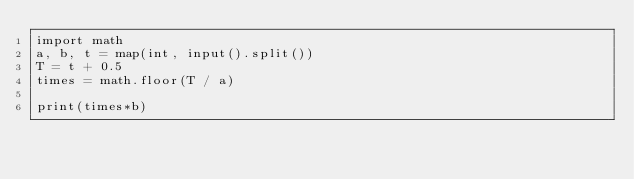<code> <loc_0><loc_0><loc_500><loc_500><_Python_>import math
a, b, t = map(int, input().split())
T = t + 0.5
times = math.floor(T / a)

print(times*b)</code> 